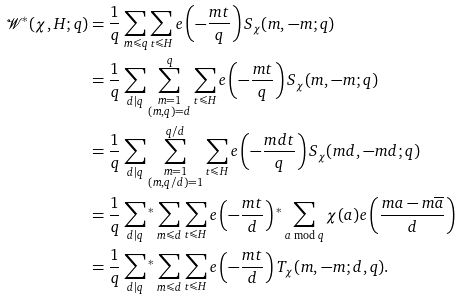<formula> <loc_0><loc_0><loc_500><loc_500>\mathcal { W } ^ { * } ( \chi , H ; q ) & = \frac { 1 } { q } \sum _ { m \leqslant q } \sum _ { t \leqslant H } e \left ( - \frac { m t } { q } \right ) S _ { \chi } ( m , - m ; q ) \\ & = \frac { 1 } { q } \sum _ { d | q } \sum _ { \substack { m = 1 \\ ( m , q ) = d } } ^ { q } \sum _ { t \leqslant H } e \left ( - \frac { m t } { q } \right ) S _ { \chi } ( m , - m ; q ) \\ & = \frac { 1 } { q } \sum _ { d | q } \sum _ { \substack { m = 1 \\ ( m , q / d ) = 1 } } ^ { q / d } \sum _ { t \leqslant H } e \left ( - \frac { m d t } { q } \right ) S _ { \chi } ( m d , - m d ; q ) \\ & = \frac { 1 } { q } \sum _ { d | q } { ^ { * } } \sum _ { m \leqslant d } \sum _ { t \leqslant H } e \left ( - \frac { m t } { d } \right ) { ^ { * } } \sum _ { a \bmod q } \chi ( a ) e \left ( \frac { m a - m \overline { a } } { d } \right ) \\ & = \frac { 1 } { q } \sum _ { d | q } { ^ { * } } \sum _ { m \leqslant d } \sum _ { t \leqslant H } e \left ( - \frac { m t } { d } \right ) T _ { \chi } ( m , - m ; d , q ) .</formula> 